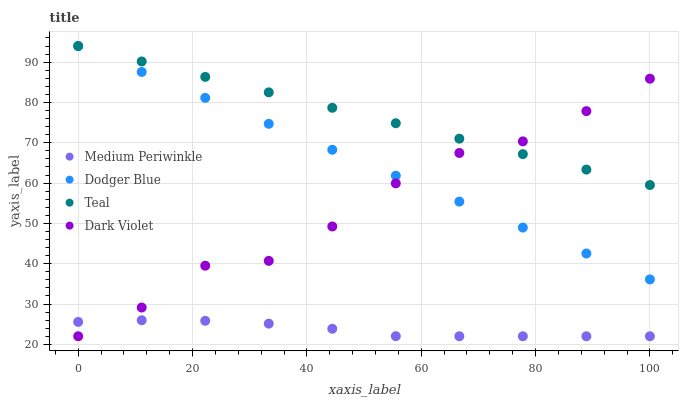Does Medium Periwinkle have the minimum area under the curve?
Answer yes or no. Yes. Does Teal have the maximum area under the curve?
Answer yes or no. Yes. Does Dark Violet have the minimum area under the curve?
Answer yes or no. No. Does Dark Violet have the maximum area under the curve?
Answer yes or no. No. Is Dodger Blue the smoothest?
Answer yes or no. Yes. Is Dark Violet the roughest?
Answer yes or no. Yes. Is Medium Periwinkle the smoothest?
Answer yes or no. No. Is Medium Periwinkle the roughest?
Answer yes or no. No. Does Medium Periwinkle have the lowest value?
Answer yes or no. Yes. Does Teal have the lowest value?
Answer yes or no. No. Does Teal have the highest value?
Answer yes or no. Yes. Does Dark Violet have the highest value?
Answer yes or no. No. Is Medium Periwinkle less than Dodger Blue?
Answer yes or no. Yes. Is Teal greater than Medium Periwinkle?
Answer yes or no. Yes. Does Dodger Blue intersect Dark Violet?
Answer yes or no. Yes. Is Dodger Blue less than Dark Violet?
Answer yes or no. No. Is Dodger Blue greater than Dark Violet?
Answer yes or no. No. Does Medium Periwinkle intersect Dodger Blue?
Answer yes or no. No. 